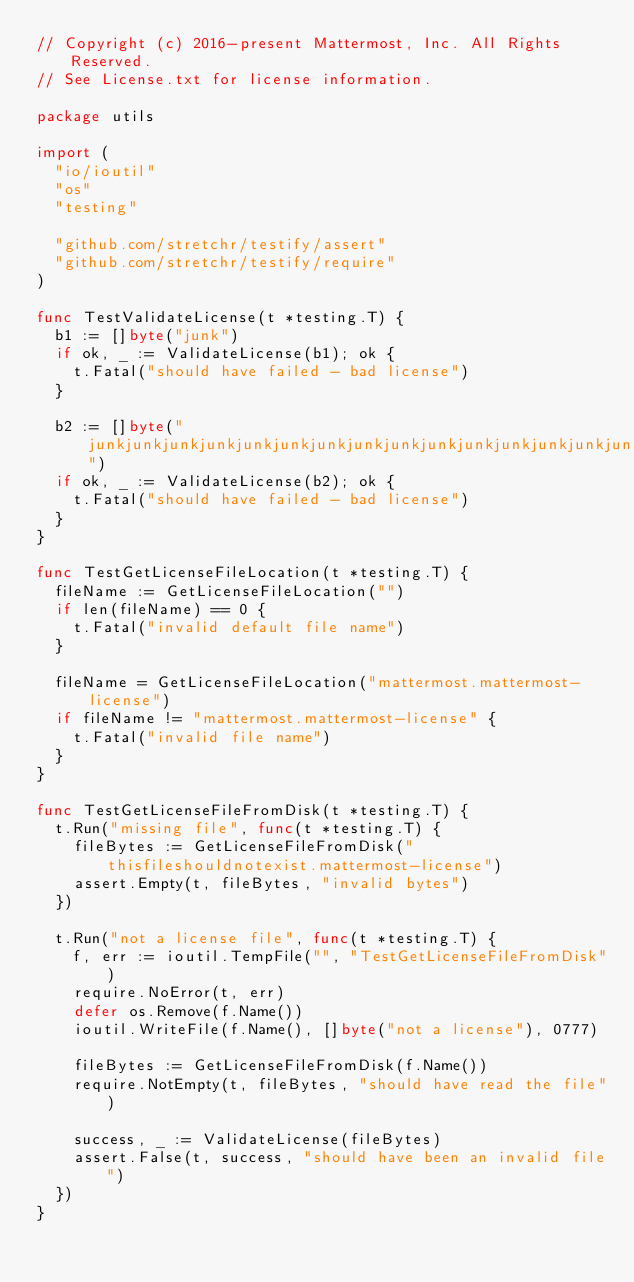<code> <loc_0><loc_0><loc_500><loc_500><_Go_>// Copyright (c) 2016-present Mattermost, Inc. All Rights Reserved.
// See License.txt for license information.

package utils

import (
	"io/ioutil"
	"os"
	"testing"

	"github.com/stretchr/testify/assert"
	"github.com/stretchr/testify/require"
)

func TestValidateLicense(t *testing.T) {
	b1 := []byte("junk")
	if ok, _ := ValidateLicense(b1); ok {
		t.Fatal("should have failed - bad license")
	}

	b2 := []byte("junkjunkjunkjunkjunkjunkjunkjunkjunkjunkjunkjunkjunkjunkjunkjunkjunkjunkjunkjunkjunkjunkjunkjunkjunkjunkjunkjunkjunkjunkjunkjunkjunkjunkjunkjunkjunkjunkjunkjunkjunkjunkjunkjunkjunkjunkjunkjunkjunkjunkjunkjunkjunkjunkjunkjunkjunkjunkjunkjunkjunkjunkjunkjunkjunkjunkjunkjunkjunkjunkjunkjunkjunkjunkjunkjunkjunkjunkjunkjunkjunkjunkjunkjunkjunkjunkjunkjunkjunkjunkjunkjunkjunkjunkjunkjunkjunkjunkjunkjunkjunkjunkjunkjunkjunkjunkjunkjunkjunkjunkjunkjunkjunkjunkjunkjunkjunkjunkjunkjunkjunkjunkjunkjunkjunkjunkjunkjunkjunkjunkjunkjunkjunkjunkjunkjunkjunkjunkjunkjunkjunkjunkjunkjunkjunkjunkjunkjunkjunkjunkjunkjunkjunkjunkjunkjunkjunkjunkjunkjunkjunkjunkjunkjunkjunkjunkjunkjunkjunkjunkjunkjunkjunkjunkjunkjunkjunkjunkjunkjunkjunkjunkjunkjunkjunkjunkjunkjunkjunkjunkjunkjunkjunkjunkjunkjunkjunkjunkjunkjunkjunkjunkjunkjunkjunkjunkjunkjunkjunkjunkjunkjunkjunkjunkjunkjunkjunkjunkjunkjunkjunkjunkjunkjunkjunkjunkjunkjunkjunkjunkjunkjunkjunkjunkjunkjunkjunkjunkjunkjunkjunkjunkjunkjunkjunkjunkjunkjunkjunkjunkjunkjunkjunkjunkjunkjunkjunkjunkjunkjunkjunkjunkjunkjunkjunkjunkjunkjunkjunkjunkjunkjunkjunkjunkjunkjunkjunkjunkjunkjunkjunkjunkjunkjunkjunkjunkjunkjunk")
	if ok, _ := ValidateLicense(b2); ok {
		t.Fatal("should have failed - bad license")
	}
}

func TestGetLicenseFileLocation(t *testing.T) {
	fileName := GetLicenseFileLocation("")
	if len(fileName) == 0 {
		t.Fatal("invalid default file name")
	}

	fileName = GetLicenseFileLocation("mattermost.mattermost-license")
	if fileName != "mattermost.mattermost-license" {
		t.Fatal("invalid file name")
	}
}

func TestGetLicenseFileFromDisk(t *testing.T) {
	t.Run("missing file", func(t *testing.T) {
		fileBytes := GetLicenseFileFromDisk("thisfileshouldnotexist.mattermost-license")
		assert.Empty(t, fileBytes, "invalid bytes")
	})

	t.Run("not a license file", func(t *testing.T) {
		f, err := ioutil.TempFile("", "TestGetLicenseFileFromDisk")
		require.NoError(t, err)
		defer os.Remove(f.Name())
		ioutil.WriteFile(f.Name(), []byte("not a license"), 0777)

		fileBytes := GetLicenseFileFromDisk(f.Name())
		require.NotEmpty(t, fileBytes, "should have read the file")

		success, _ := ValidateLicense(fileBytes)
		assert.False(t, success, "should have been an invalid file")
	})
}
</code> 